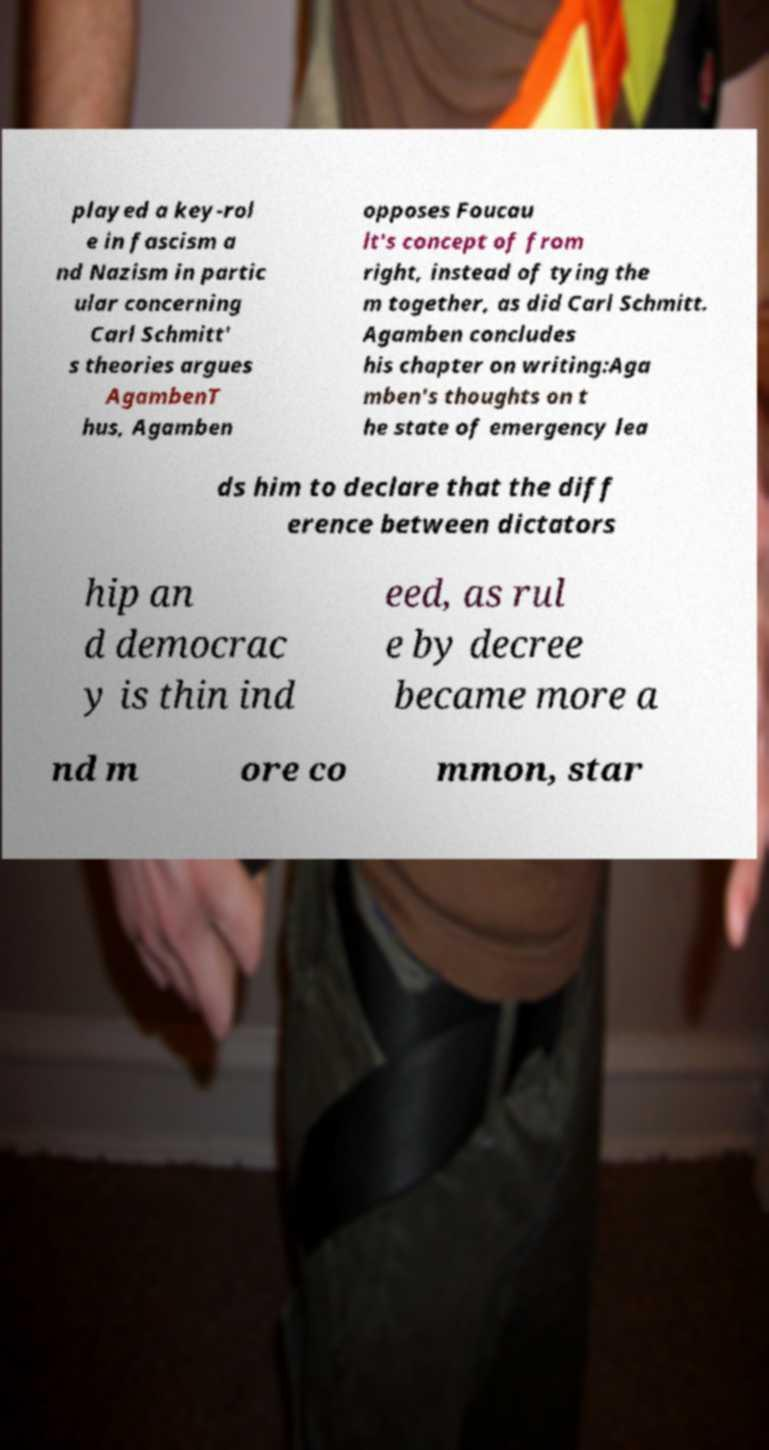Please identify and transcribe the text found in this image. played a key-rol e in fascism a nd Nazism in partic ular concerning Carl Schmitt' s theories argues AgambenT hus, Agamben opposes Foucau lt's concept of from right, instead of tying the m together, as did Carl Schmitt. Agamben concludes his chapter on writing:Aga mben's thoughts on t he state of emergency lea ds him to declare that the diff erence between dictators hip an d democrac y is thin ind eed, as rul e by decree became more a nd m ore co mmon, star 